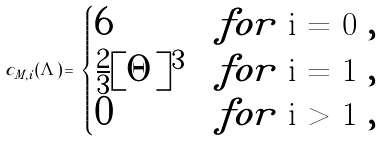<formula> <loc_0><loc_0><loc_500><loc_500>c _ { M , i } ( \Lambda ) \, = \, \begin{cases} 6 & f o r $ i = 0 $ , \\ \frac { 2 } { 3 } [ \Theta ] ^ { 3 } & f o r $ i = 1 $ , \\ 0 & f o r $ i > 1 $ , \end{cases}</formula> 